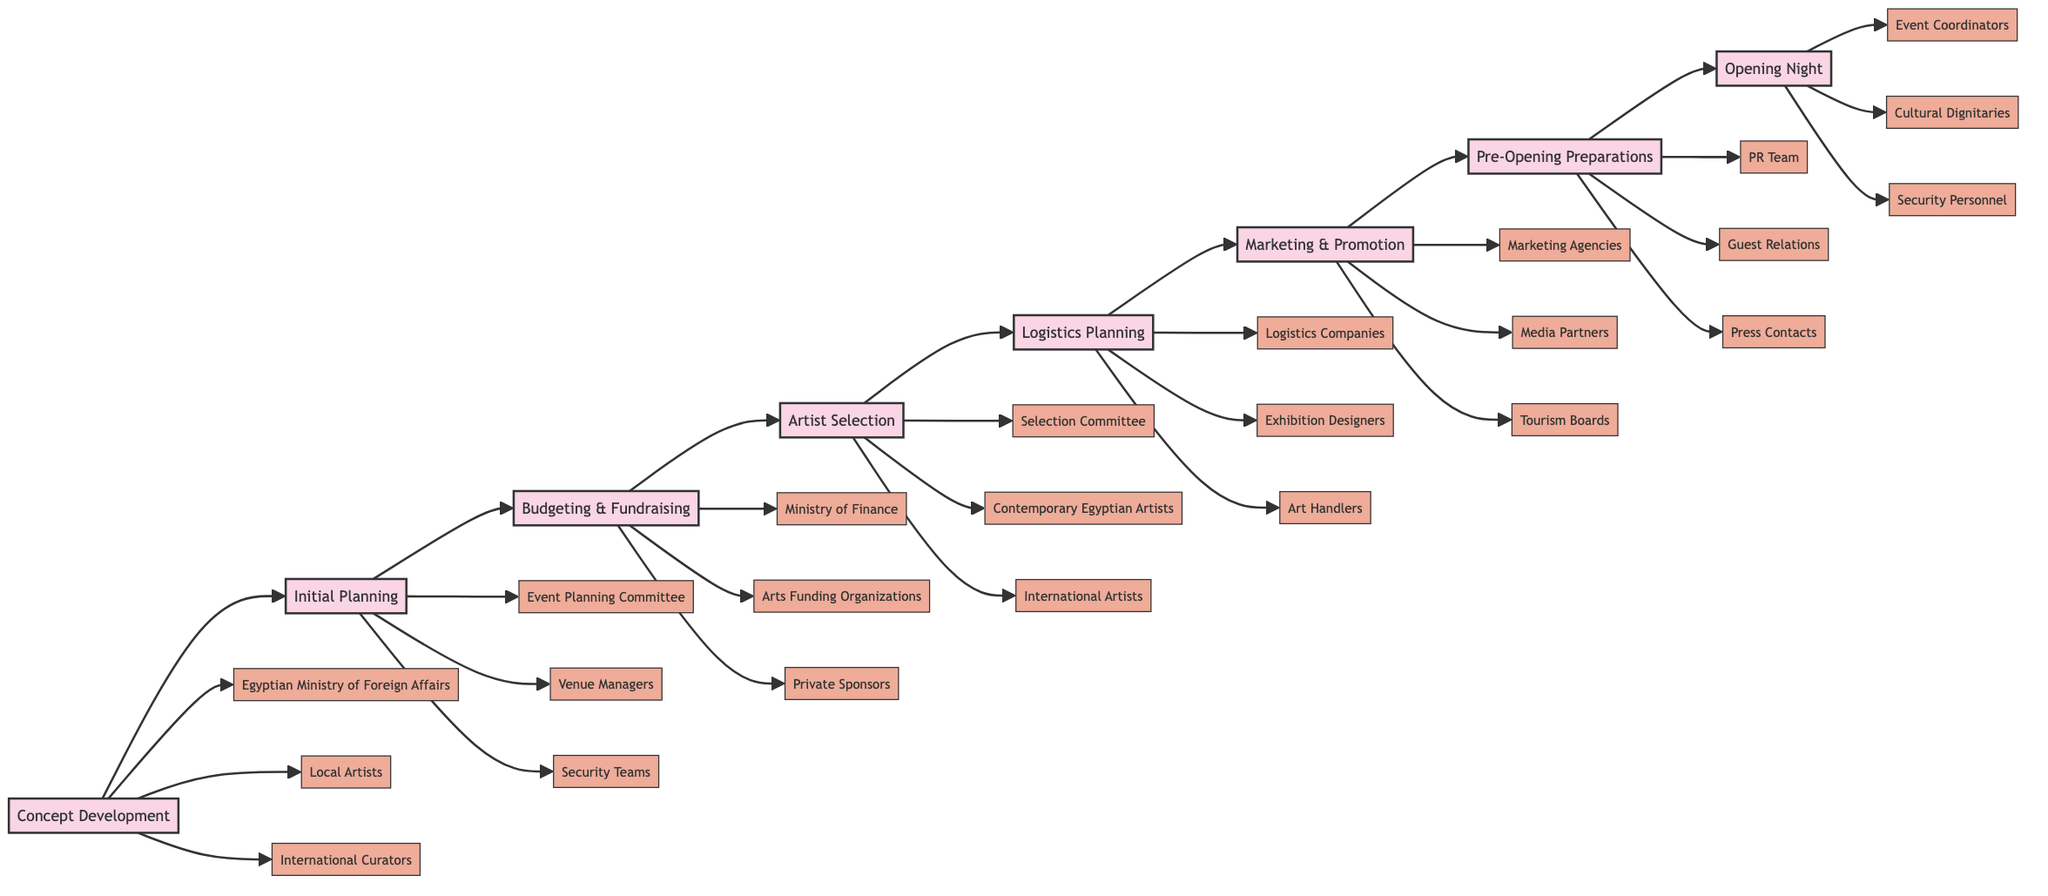What is the first phase in the exhibition organization process? The flowchart visually begins with the node labeled "Concept Development," indicating that this is the first phase in the process.
Answer: Concept Development How many key entities are associated with the "Artist Selection" phase? The "Artist Selection" phase in the diagram is connected to three specific key entities: the Selection Committee, Contemporary Egyptian Artists, and International Artists.
Answer: 3 Which phase directly follows "Budgeting & Fundraising"? The flowchart shows an arrow leading from "Budgeting & Fundraising" to the "Artist Selection" phase, indicating that "Artist Selection" immediately follows it.
Answer: Artist Selection What are the key entities linked to the "Logistics Planning" phase? In the diagram, the "Logistics Planning" phase is associated with three entities: Logistics Companies, Exhibition Designers, and Art Handlers, as indicated by the connecting lines from this phase.
Answer: Logistics Companies, Exhibition Designers, Art Handlers Which phase has "Media Partners" as a key entity? The "Marketing & Promotion" phase has "Media Partners" listed among its key entities in the diagram, as this entity is connected to that phase.
Answer: Marketing & Promotion What is the last phase indicated in the flowchart? The flowchart ends with the "Opening Night" phase, which is the final step in the exhibition organization process as shown by the sequence of arrows leading to it.
Answer: Opening Night How many phases are shown in the flowchart? The diagram enumerates a total of eight phases spanning from "Concept Development" to "Opening Night," confirming that there are eight distinct phases.
Answer: 8 Which team is responsible for managing attendance on the opening night? The diagram highlights that the "Event Coordinators" are the key entity designated for managing attendance during the "Opening Night."
Answer: Event Coordinators In which phase do "Cultural Dignitaries" appear as a key entity? "Cultural Dignitaries" appear in the "Opening Night" phase, as indicated by their direct association with this last step in the flowchart.
Answer: Opening Night 